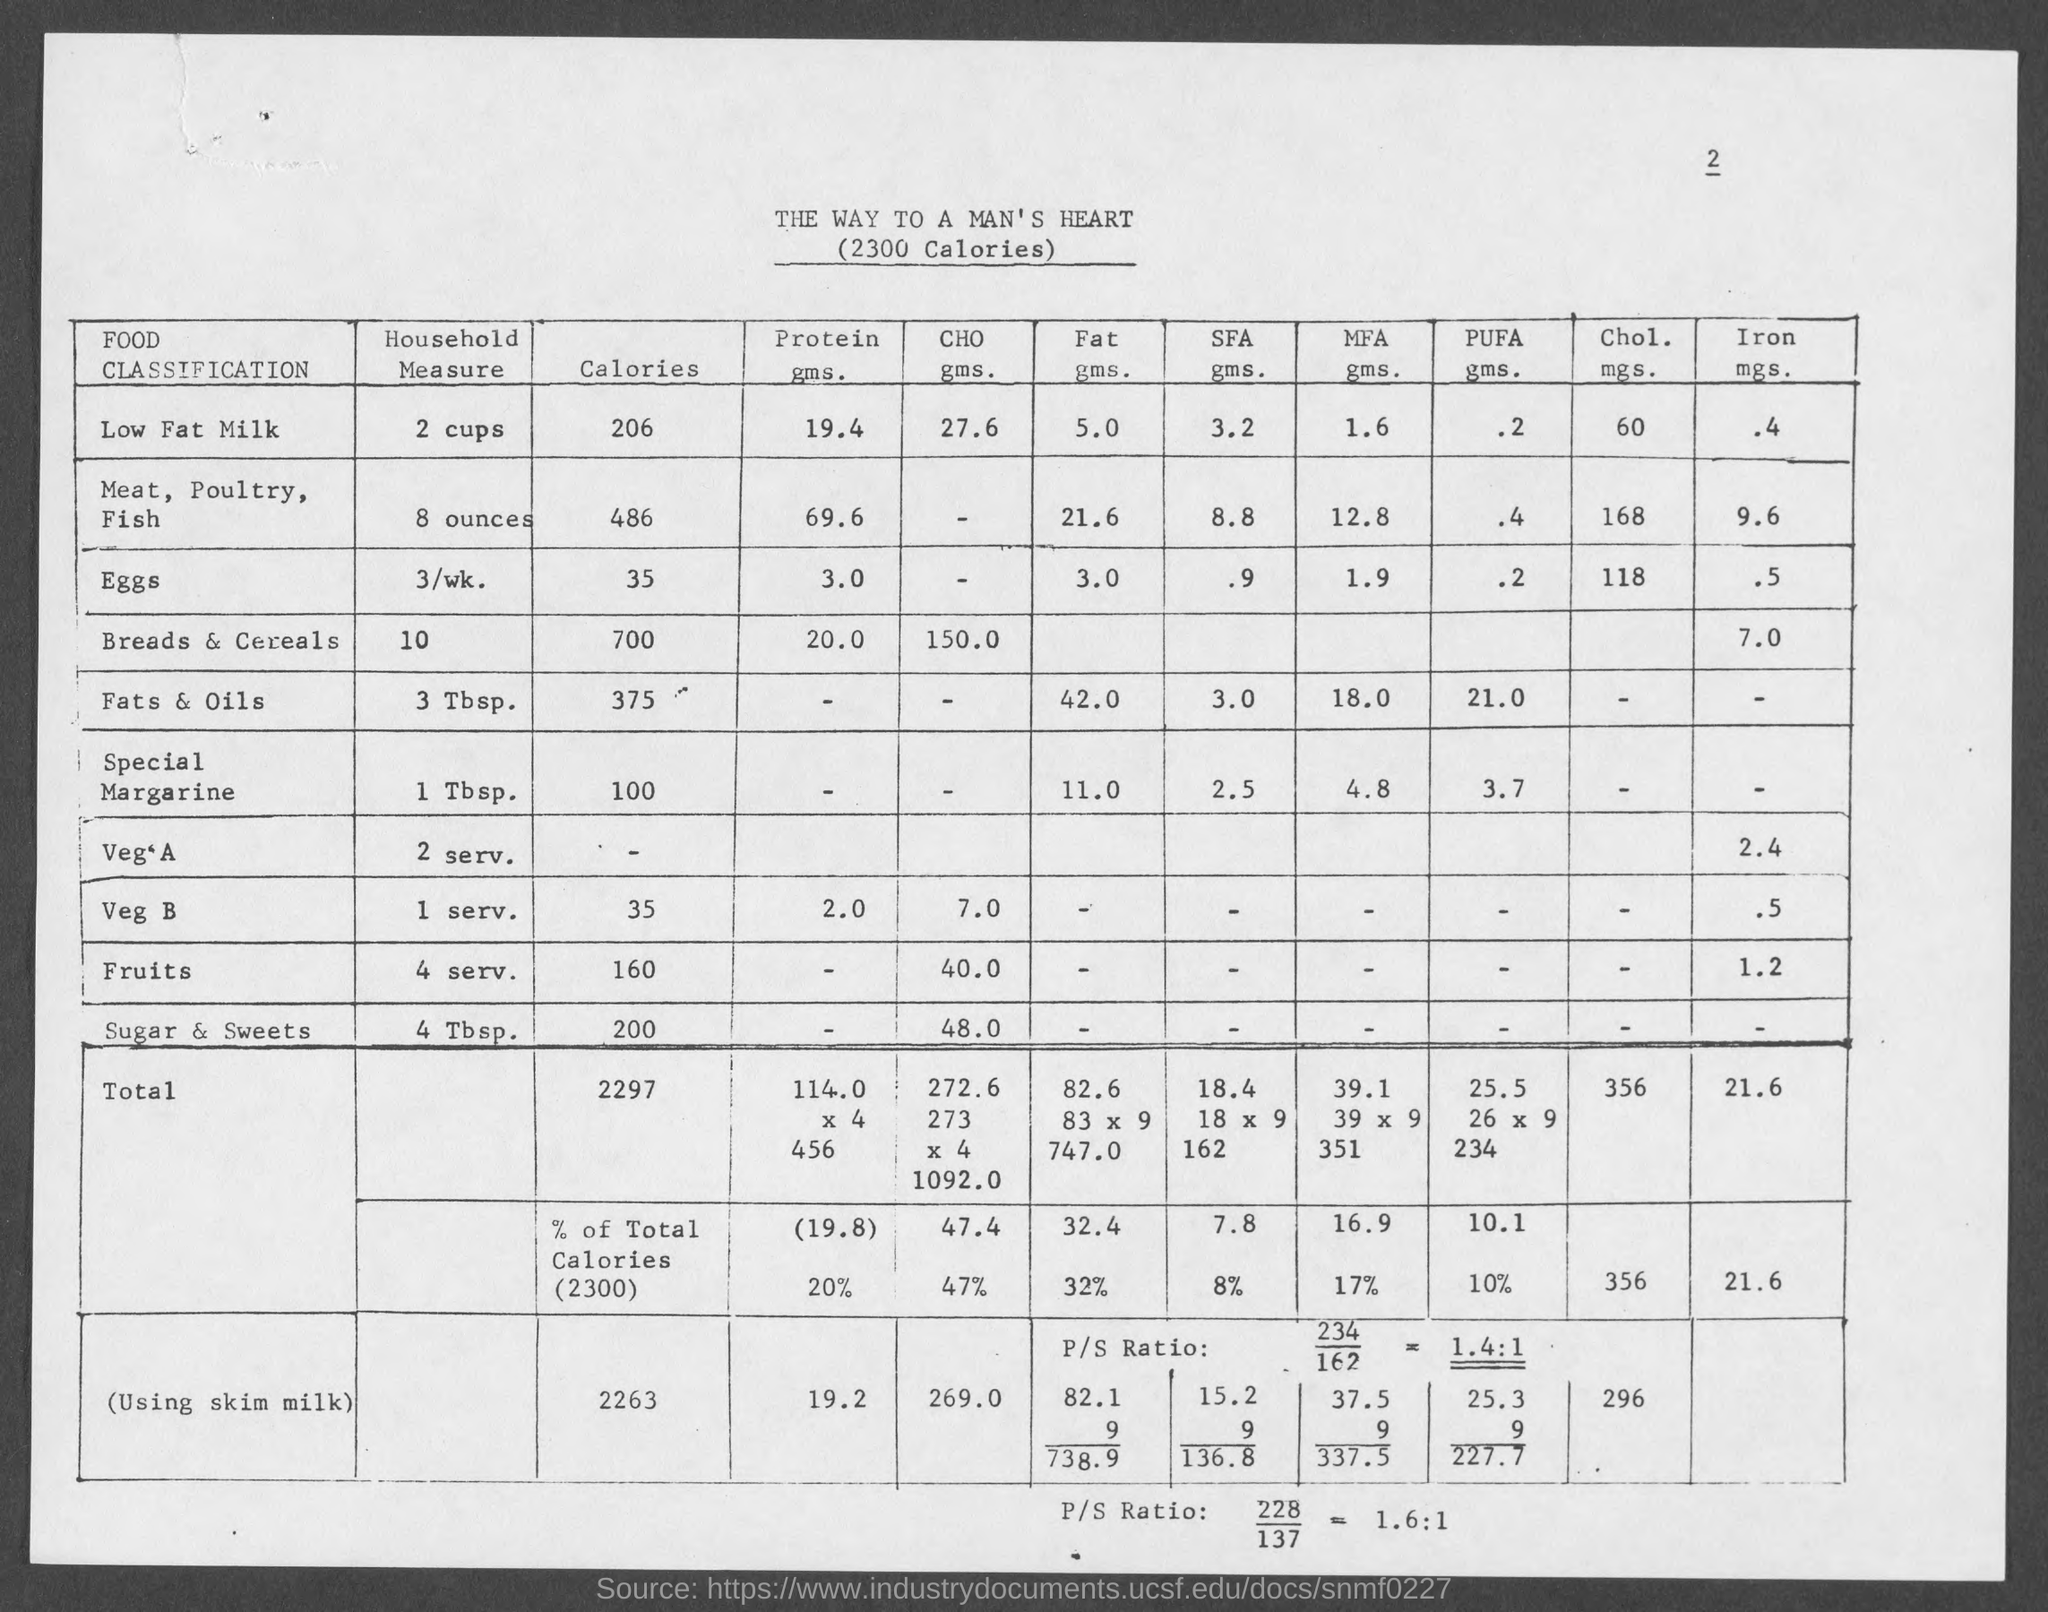What is the amount of calories in 2 cups of low fat milk ?
Your answer should be very brief. 206 cal. What is the amount of protein in 2 cups of low fat milk ?
Make the answer very short. 19.4 gms. What is the amount of fat in 2 cups of low fat milk ?
Keep it short and to the point. 5. What is the amount of cholesterol in 2 cups of low fat milk ?
Provide a succinct answer. 60 mgs. What is the amount of iron in 2 cups of low fat milk ?
Provide a succinct answer. .4  mgs. What is the amount of calories in 8 ounces in meat, poultry, fish ?
Provide a succinct answer. 486 cal. What is the amount of protein in 8 ounces in meat, poultry, fish?
Keep it short and to the point. 69.6 gms. What is the amount of fat in 8 ounces in meat, poultry, fish?
Your answer should be very brief. 21.6. What is the amount of cholesterol in 8 ounces in meat, poultry, fish?
Keep it short and to the point. 168. What is the amount of iron in 8 ounces of meat, poultry, fish?
Keep it short and to the point. 9.6. 